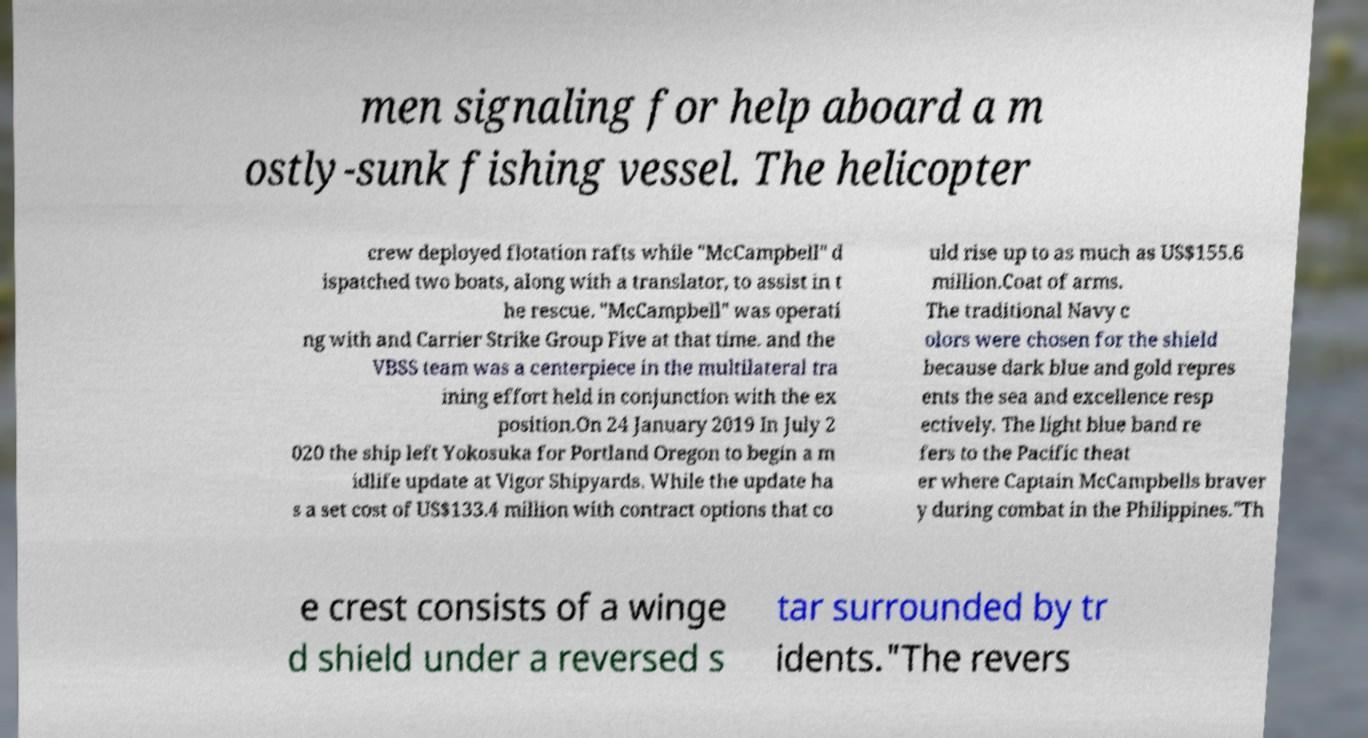What messages or text are displayed in this image? I need them in a readable, typed format. men signaling for help aboard a m ostly-sunk fishing vessel. The helicopter crew deployed flotation rafts while "McCampbell" d ispatched two boats, along with a translator, to assist in t he rescue. "McCampbell" was operati ng with and Carrier Strike Group Five at that time. and the VBSS team was a centerpiece in the multilateral tra ining effort held in conjunction with the ex position.On 24 January 2019 In July 2 020 the ship left Yokosuka for Portland Oregon to begin a m idlife update at Vigor Shipyards. While the update ha s a set cost of US$133.4 million with contract options that co uld rise up to as much as US$155.6 million.Coat of arms. The traditional Navy c olors were chosen for the shield because dark blue and gold repres ents the sea and excellence resp ectively. The light blue band re fers to the Pacific theat er where Captain McCampbells braver y during combat in the Philippines."Th e crest consists of a winge d shield under a reversed s tar surrounded by tr idents."The revers 